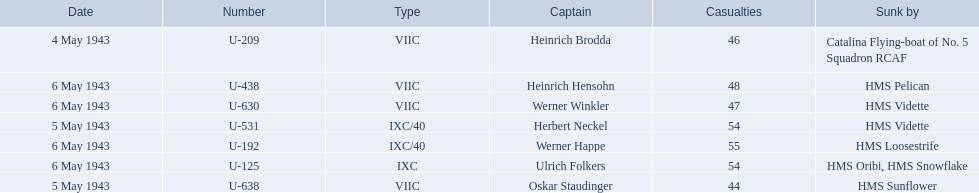Who were the captains in the ons 5 convoy? Heinrich Brodda, Oskar Staudinger, Herbert Neckel, Werner Happe, Ulrich Folkers, Werner Winkler, Heinrich Hensohn. Which ones lost their u-boat on may 5? Oskar Staudinger, Herbert Neckel. Of those, which one is not oskar staudinger? Herbert Neckel. 